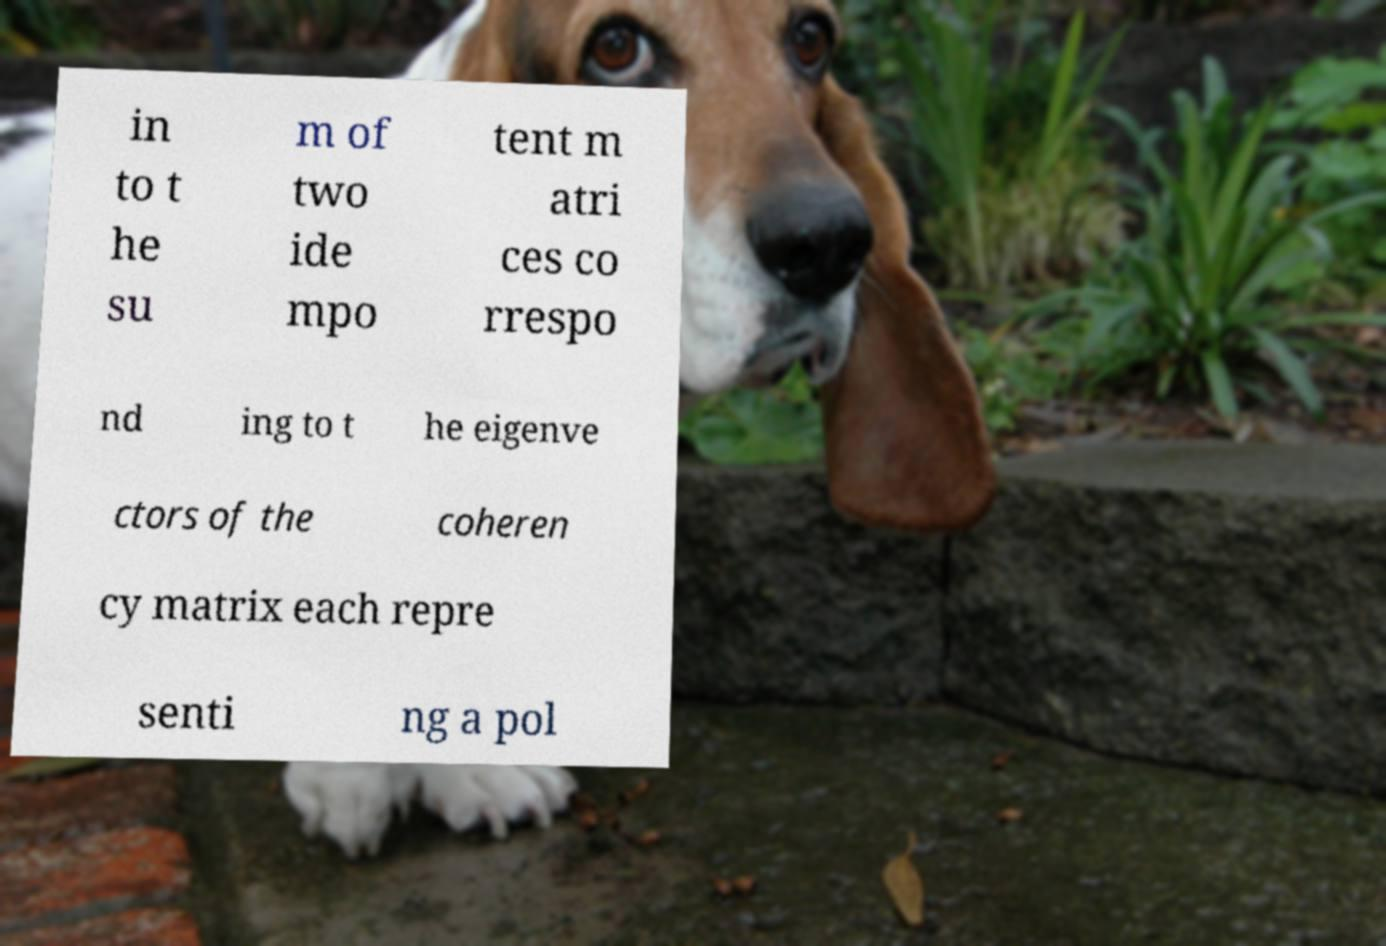There's text embedded in this image that I need extracted. Can you transcribe it verbatim? in to t he su m of two ide mpo tent m atri ces co rrespo nd ing to t he eigenve ctors of the coheren cy matrix each repre senti ng a pol 